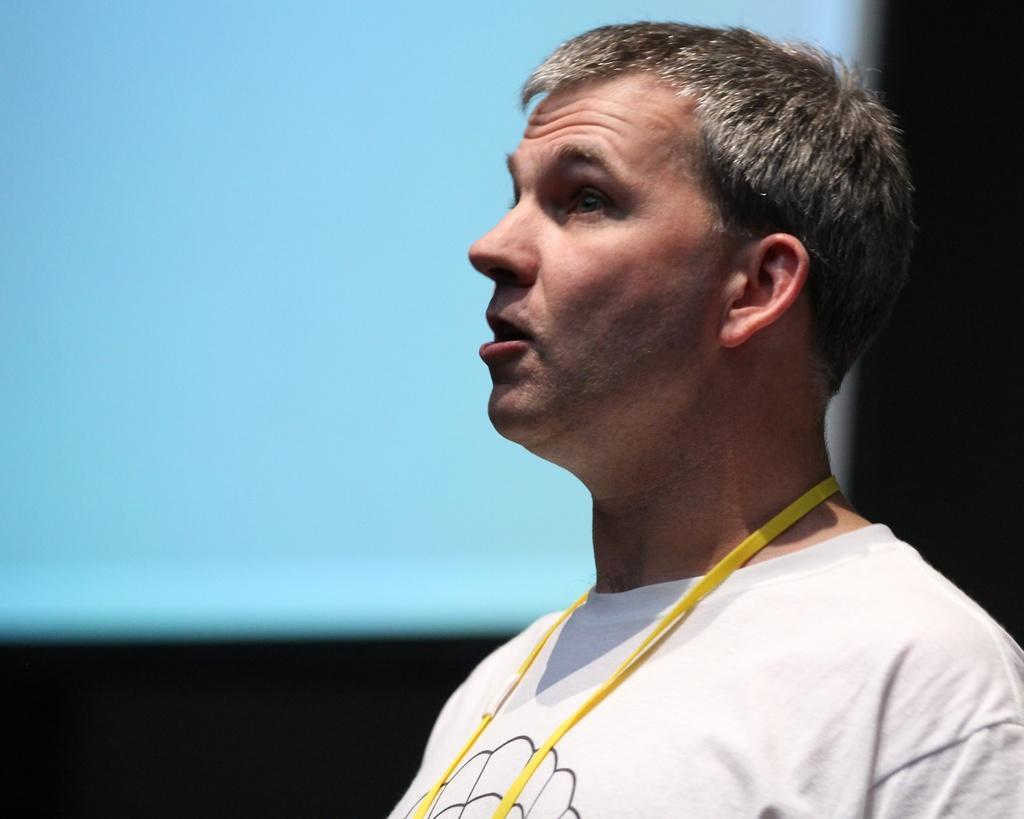In one or two sentences, can you explain what this image depicts? Bottom right side of the image a man is standing and watching. Behind him there is a screen. 